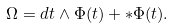Convert formula to latex. <formula><loc_0><loc_0><loc_500><loc_500>\Omega = d t \wedge \Phi ( t ) + * \Phi ( t ) .</formula> 